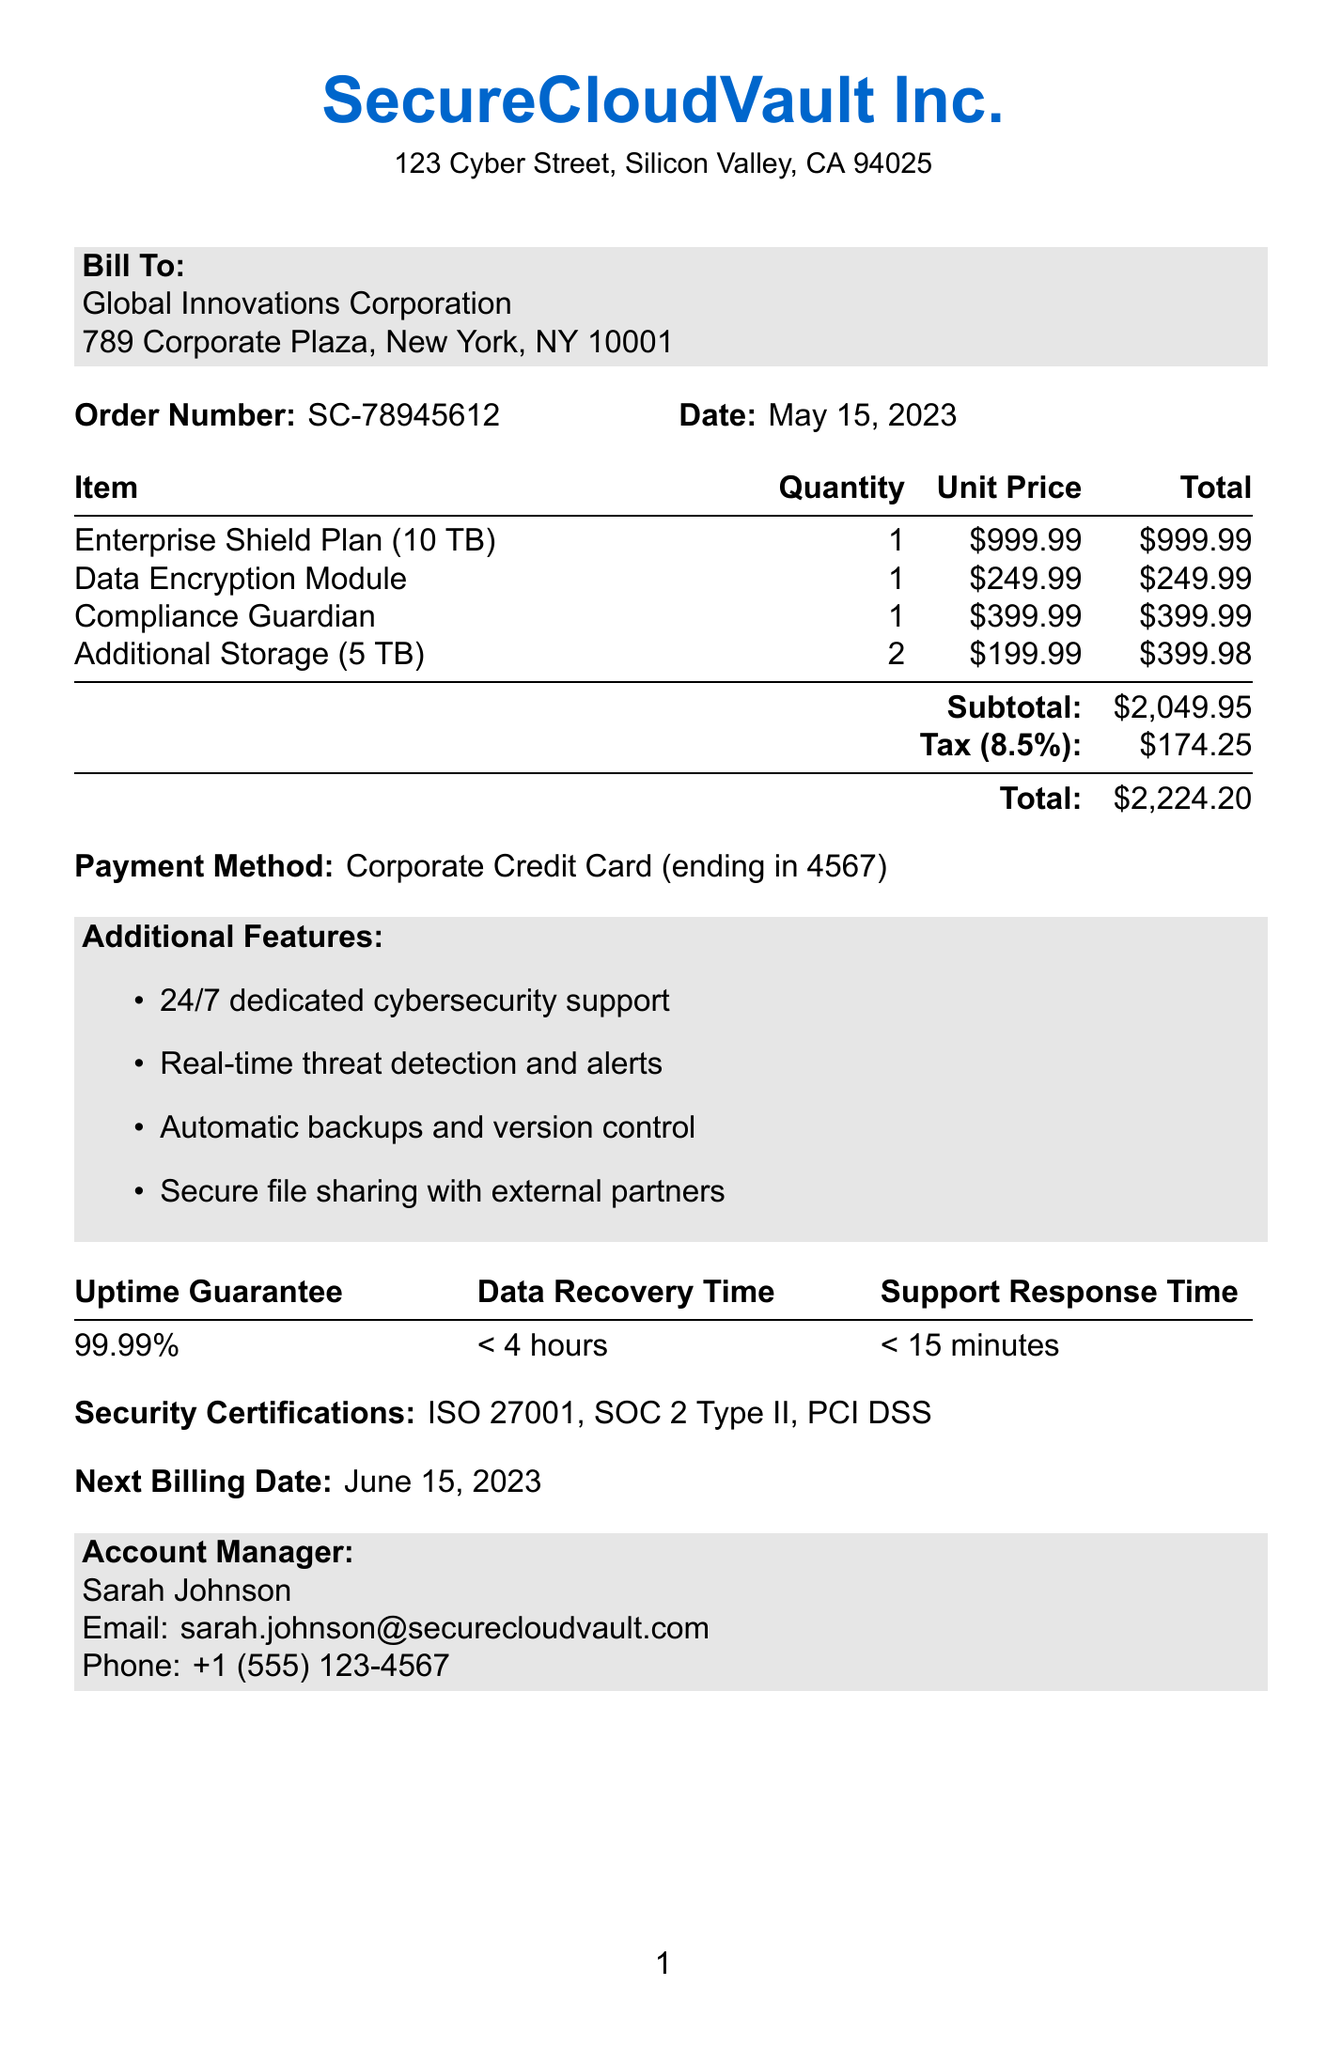what is the order number? The order number is given in the document as a unique identifier for the transaction.
Answer: SC-78945612 who is the account manager? The account manager's name is listed in the document under the Account Manager section.
Answer: Sarah Johnson what is the total amount due? The total amount due is calculated from subtotal plus tax; this value is explicitly stated in the document.
Answer: $2,224.20 how many TB does the Enterprise Shield Plan include? The capacity of the Enterprise Shield Plan is specified in the item's details.
Answer: 10 TB what is the tax rate applied? The tax rate is stated in the document and is relevant for calculating the final total amount.
Answer: 8.5% what is the next billing date? The next billing date is provided in the document as the upcoming date for payment.
Answer: June 15, 2023 what type of data protection is included with the Data Encryption Module? The description of the Data Encryption Module specifies the level of encryption used for data protection.
Answer: 256-bit AES encryption how many quantities of Additional Storage were purchased? The quantity of Additional Storage is explicitly listed under the items in the document.
Answer: 2 what is the uptime guarantee for the services? The uptime guarantee is a critical performance metric specified in the service level agreement section.
Answer: 99.99% 